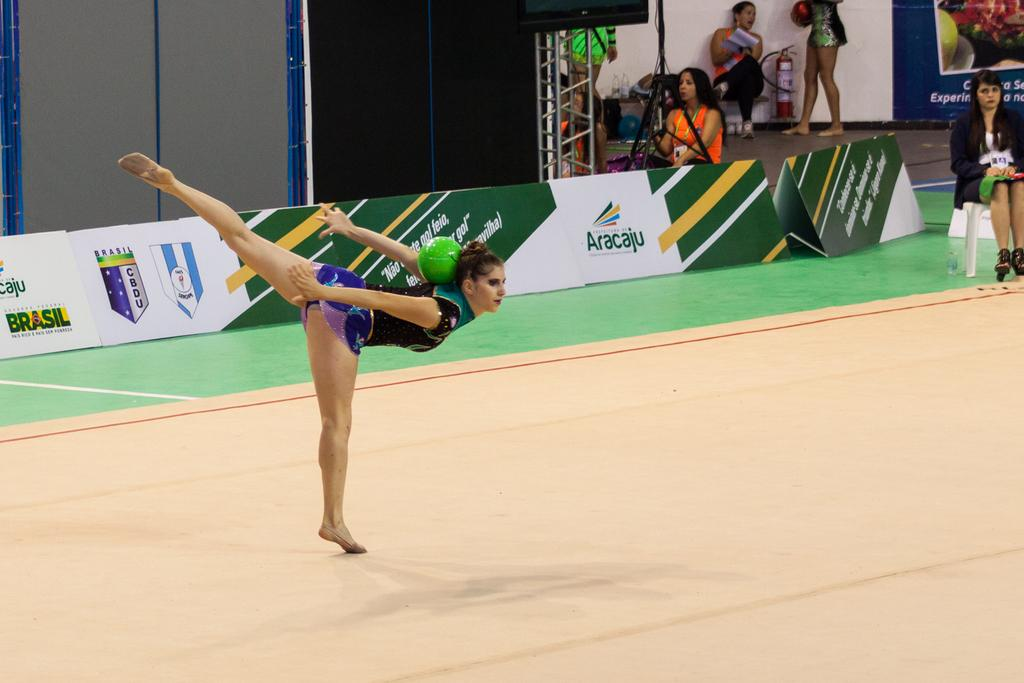<image>
Relay a brief, clear account of the picture shown. The games that are being played here are in Aracaju 